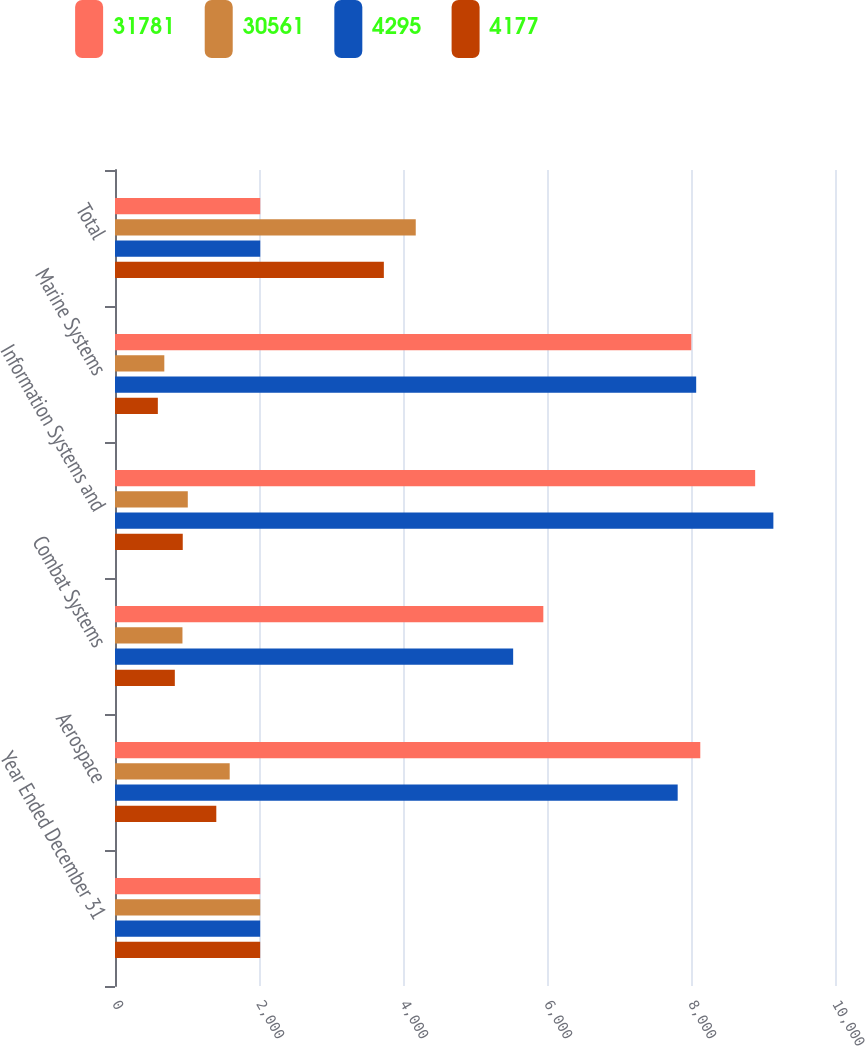Convert chart to OTSL. <chart><loc_0><loc_0><loc_500><loc_500><stacked_bar_chart><ecel><fcel>Year Ended December 31<fcel>Aerospace<fcel>Combat Systems<fcel>Information Systems and<fcel>Marine Systems<fcel>Total<nl><fcel>31781<fcel>2017<fcel>8129<fcel>5949<fcel>8891<fcel>8004<fcel>2017<nl><fcel>30561<fcel>2017<fcel>1593<fcel>937<fcel>1011<fcel>685<fcel>4177<nl><fcel>4295<fcel>2016<fcel>7815<fcel>5530<fcel>9144<fcel>8072<fcel>2017<nl><fcel>4177<fcel>2016<fcel>1407<fcel>831<fcel>941<fcel>595<fcel>3734<nl></chart> 